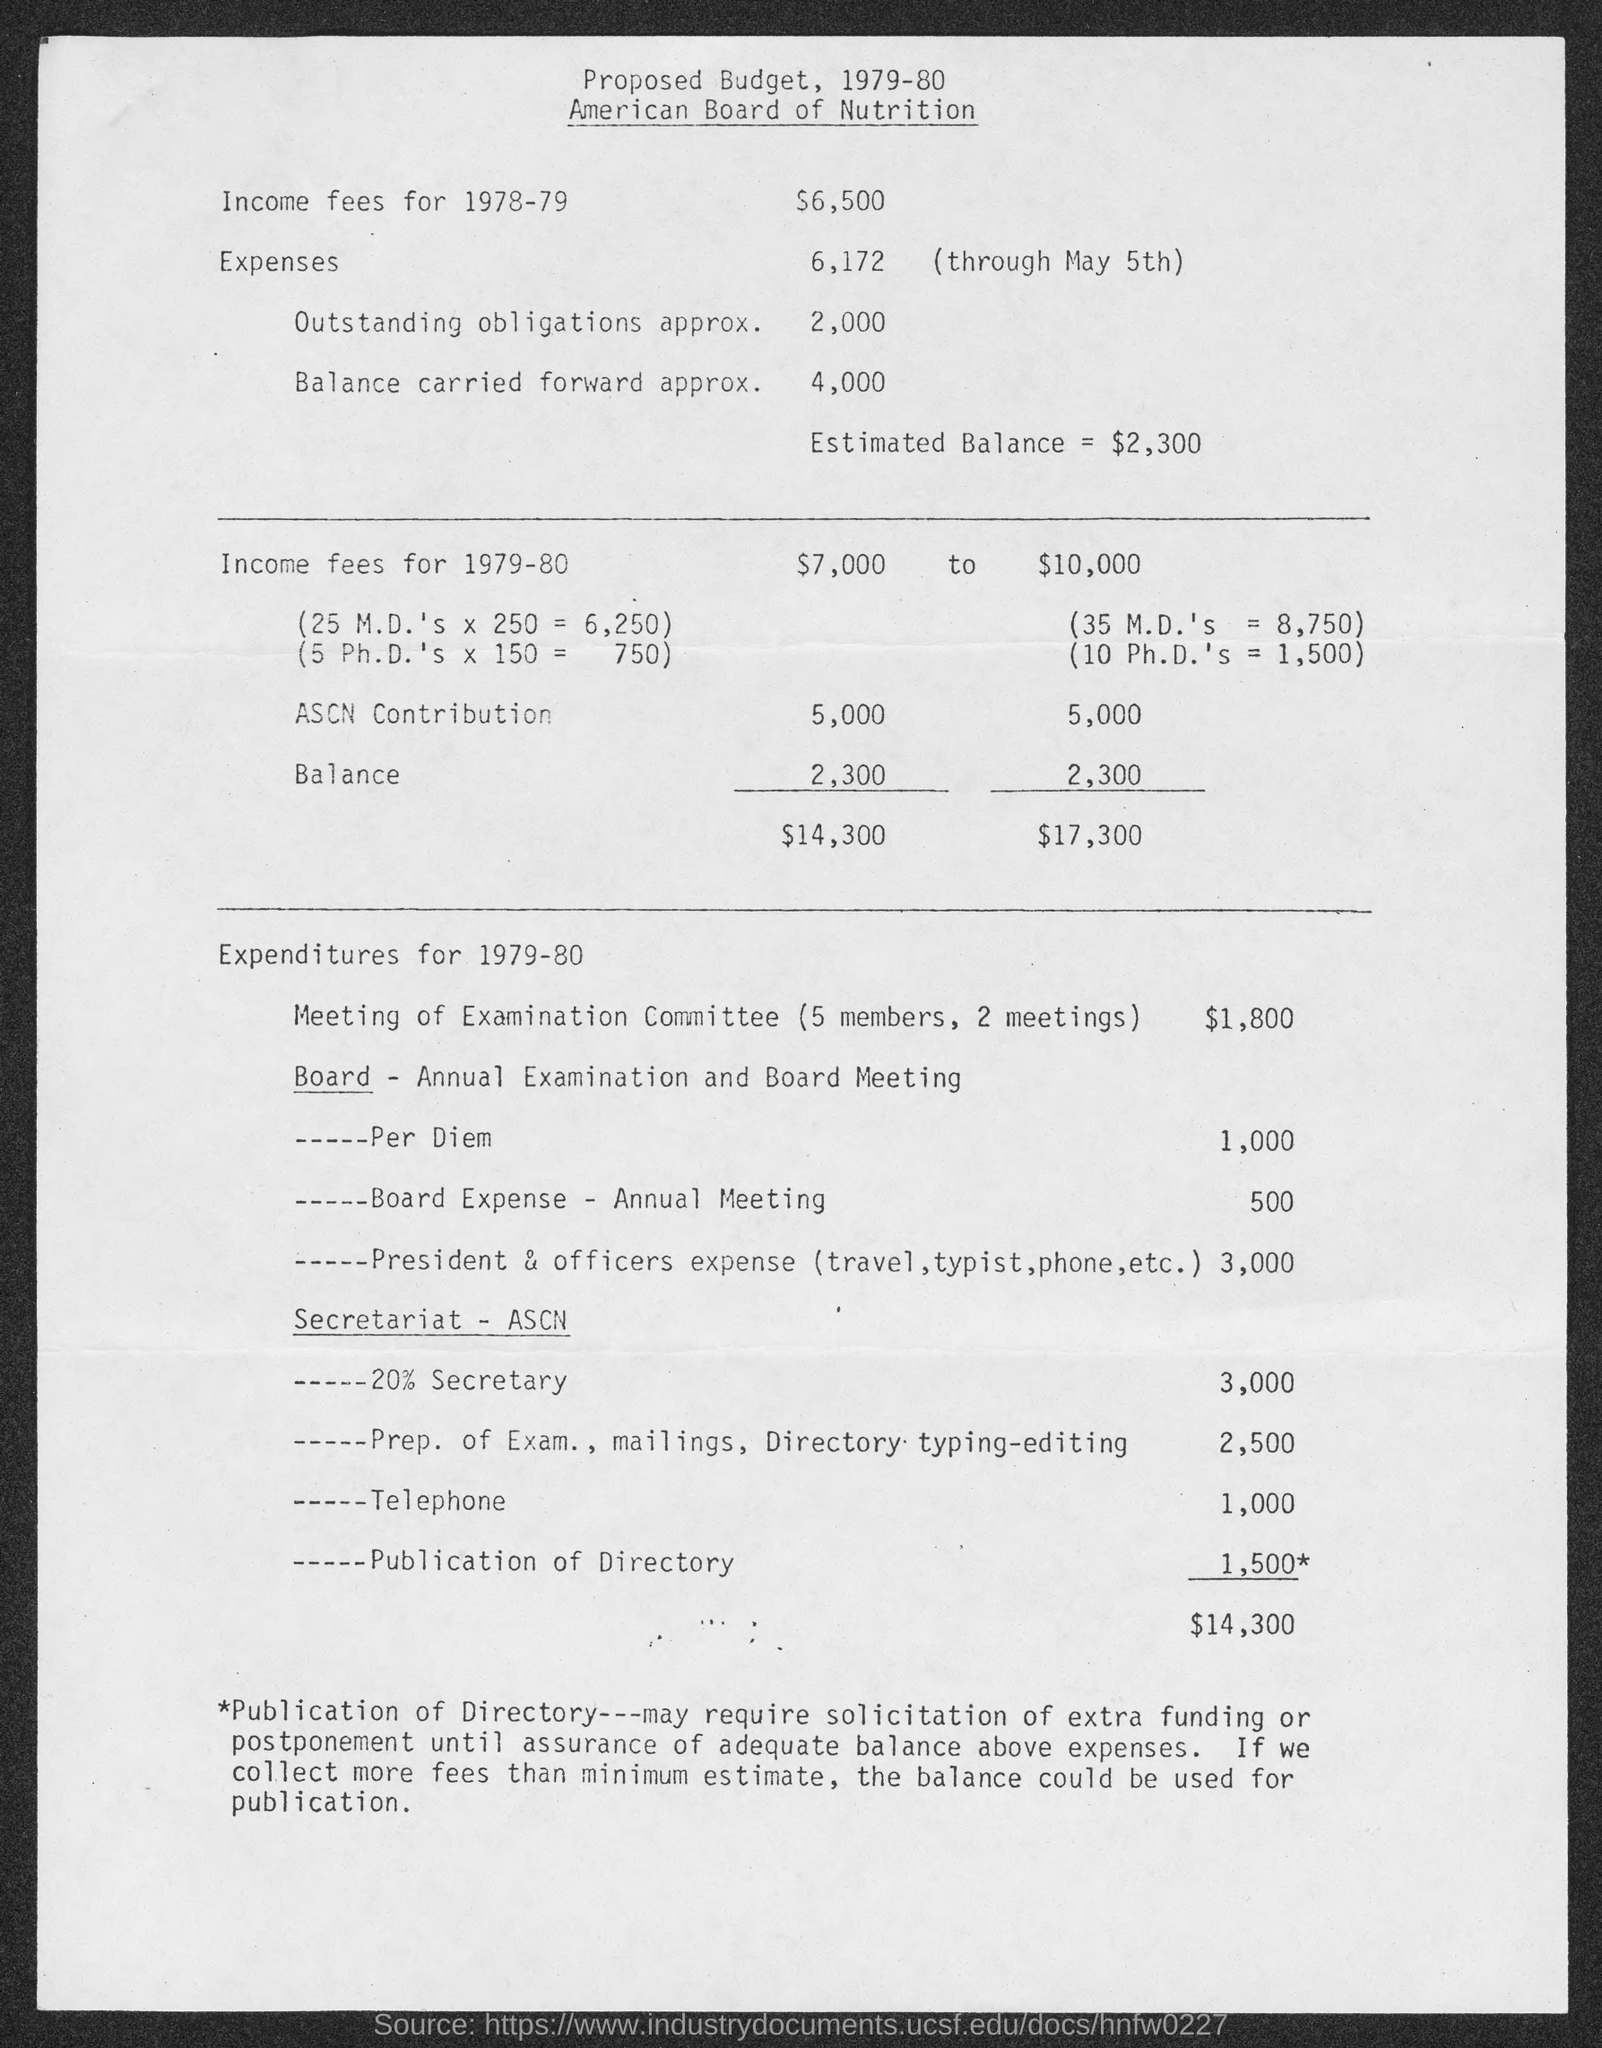List a handful of essential elements in this visual. The proposed budget for total expenditure for the year 1979-80 is $14,300. The proposed budget for a meeting of an Examination Committee with five members, consisting of two meetings, is $1,800. The proposed budget for income fees for the year 1979-80 is between $7,000 and $10,000. For the fiscal year 1978-79, the proposed budget for income-based fees is $6,500. 